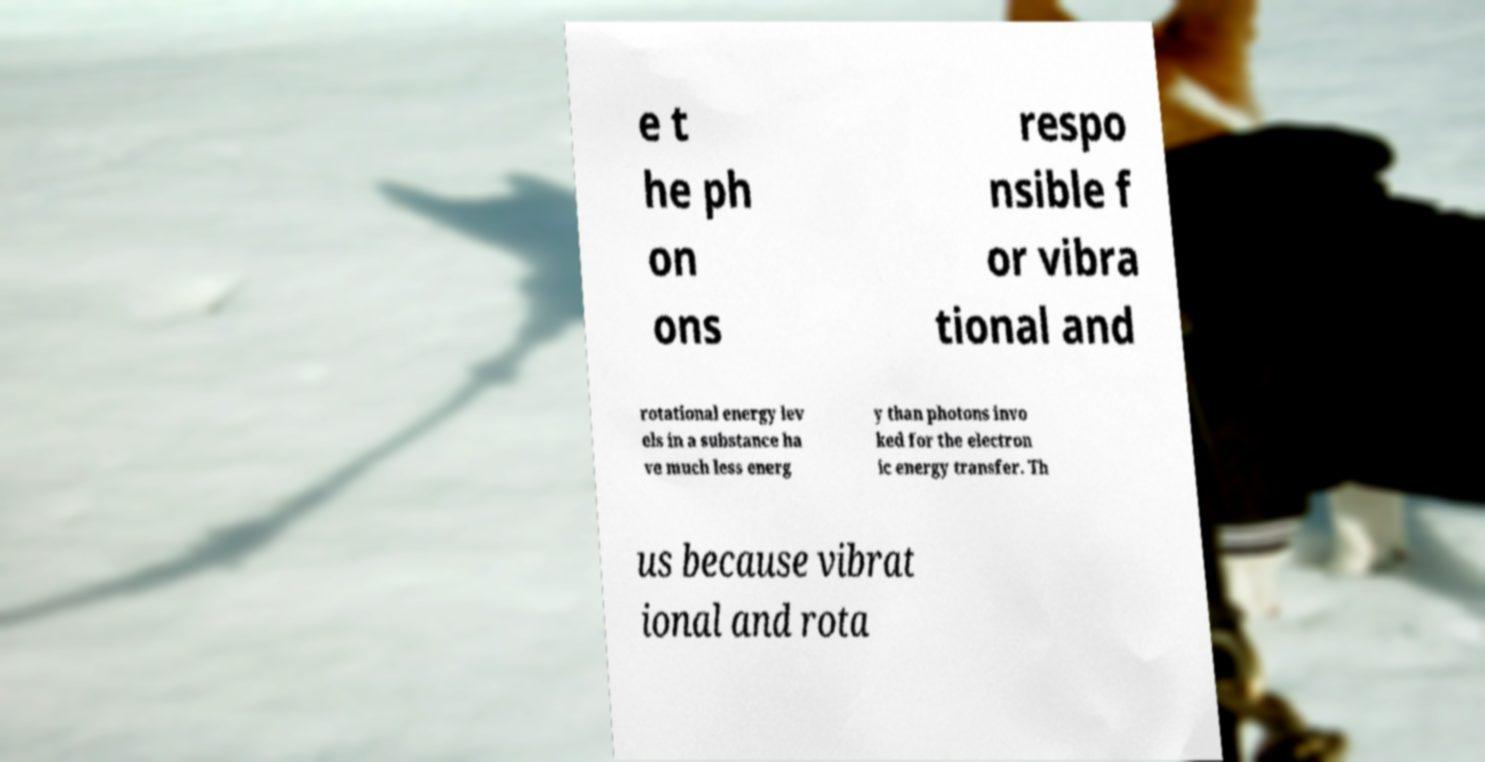Can you accurately transcribe the text from the provided image for me? e t he ph on ons respo nsible f or vibra tional and rotational energy lev els in a substance ha ve much less energ y than photons invo ked for the electron ic energy transfer. Th us because vibrat ional and rota 